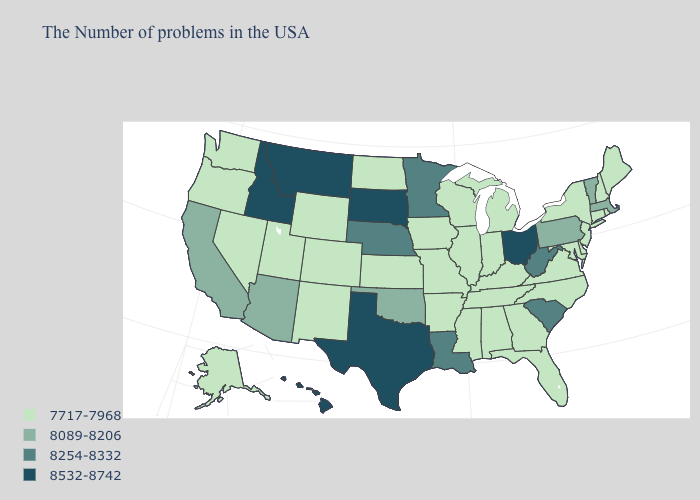Is the legend a continuous bar?
Answer briefly. No. What is the value of Alabama?
Quick response, please. 7717-7968. What is the value of Missouri?
Be succinct. 7717-7968. Does Montana have the highest value in the West?
Answer briefly. Yes. What is the lowest value in the West?
Write a very short answer. 7717-7968. What is the value of Pennsylvania?
Quick response, please. 8089-8206. What is the value of Florida?
Quick response, please. 7717-7968. Does Massachusetts have the highest value in the Northeast?
Be succinct. Yes. Does the map have missing data?
Keep it brief. No. Does Maryland have the lowest value in the South?
Write a very short answer. Yes. Does Delaware have the lowest value in the South?
Concise answer only. Yes. Which states hav the highest value in the MidWest?
Answer briefly. Ohio, South Dakota. What is the lowest value in the USA?
Short answer required. 7717-7968. What is the value of Pennsylvania?
Give a very brief answer. 8089-8206. What is the value of Alaska?
Short answer required. 7717-7968. 